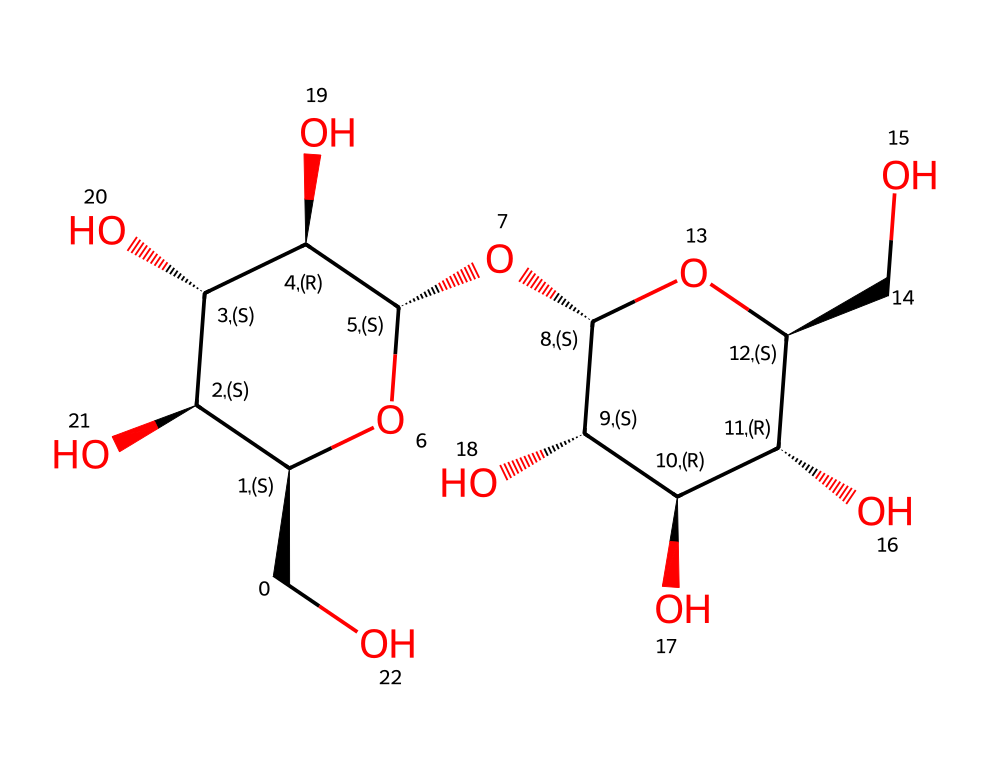how many carbon atoms are in maltodextrin? By analyzing the SMILES representation, we can identify the carbon atoms (C). The structure reveals that there are multiple interconnected carbon atoms, and upon careful counting, we find a total of 12 carbon atoms.
Answer: 12 how many oxygen atoms are present in maltodextrin? The SMILES representation includes several "O" symbols, which denote oxygen atoms. By counting these symbols in the structure, we find there are 10 oxygen atoms.
Answer: 10 does maltodextrin contain any chiral centers? A chiral center is typically a carbon atom attached to four different groups. Analyzing the structure, we see several carbon atoms with multiple hydroxyl (OH) groups, which indicate chirality. This indicates that maltodextrin has multiple chiral centers.
Answer: yes what is the molecular formula of maltodextrin? By identifying and counting the atoms in the SMILES format, we can construct the molecular formula. The counts yield C12H22O10, which corresponds to maltodextrin.
Answer: C12H22O10 is maltodextrin a monosaccharide, disaccharide, or polysaccharide? Based on its structure, maltodextrin is a polysaccharide, as it is composed of multiple sugar units (glucose units) linked together, rather than a single unit.
Answer: polysaccharide what functional groups are present in maltodextrin? The SMILES shows multiple hydroxyl (-OH) groups, which are characteristic of carbohydrates. These hydroxyl groups are the primary functional groups present in maltodextrin.
Answer: hydroxyl groups 